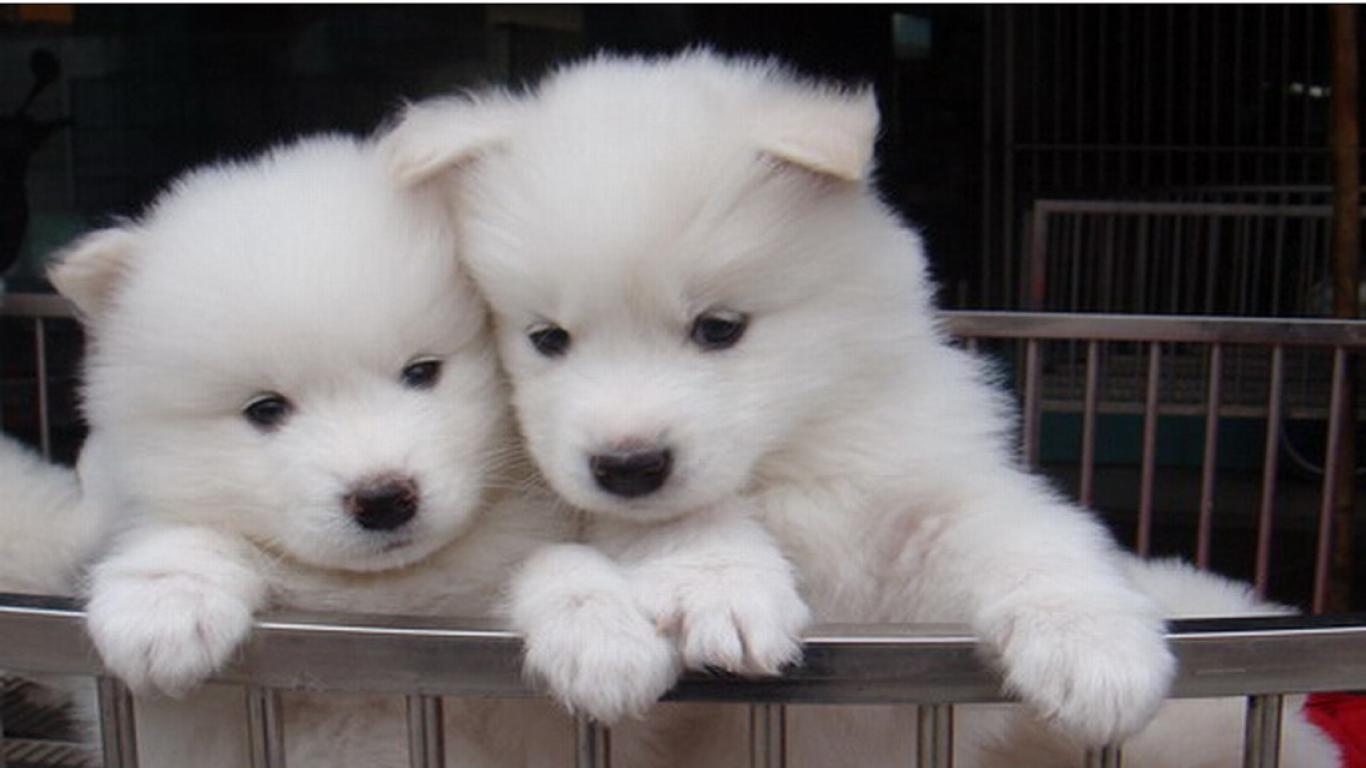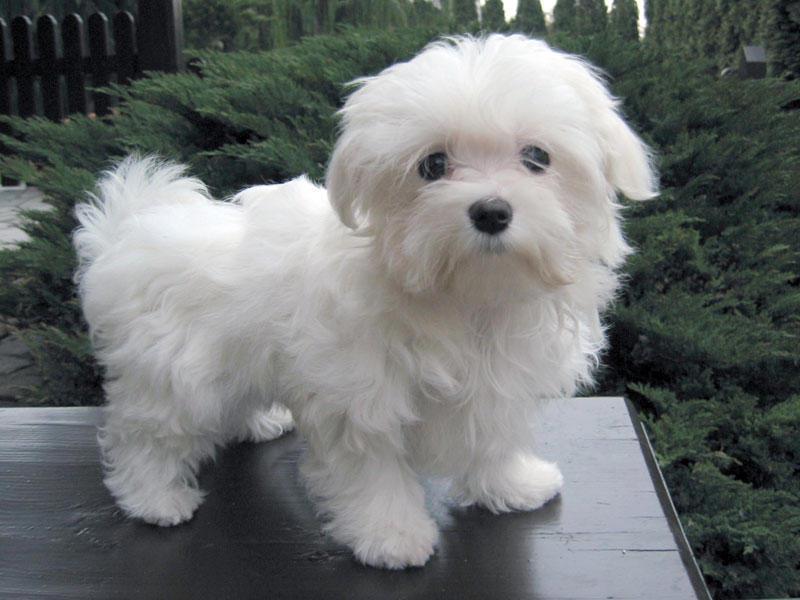The first image is the image on the left, the second image is the image on the right. Assess this claim about the two images: "One image contains twice as many white puppies as the other image and features puppies with their heads touching.". Correct or not? Answer yes or no. Yes. The first image is the image on the left, the second image is the image on the right. Examine the images to the left and right. Is the description "There are at most two dogs." accurate? Answer yes or no. No. 